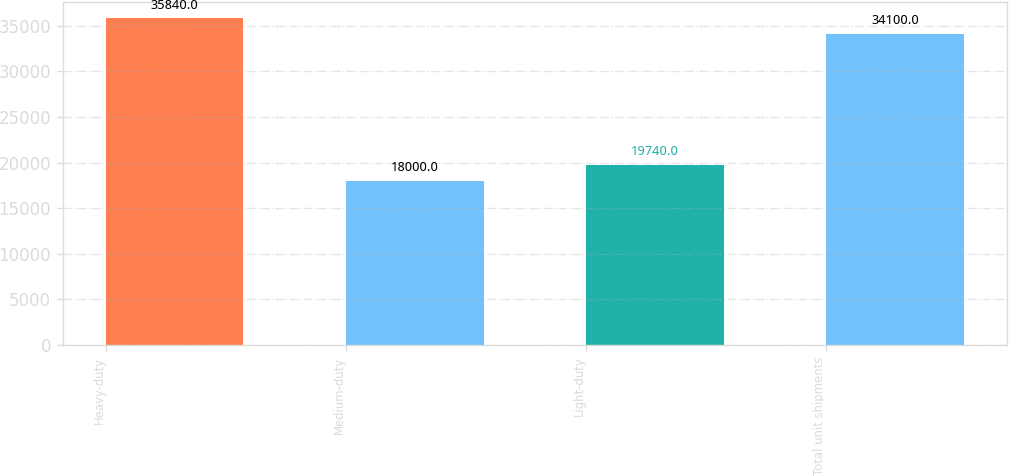<chart> <loc_0><loc_0><loc_500><loc_500><bar_chart><fcel>Heavy-duty<fcel>Medium-duty<fcel>Light-duty<fcel>Total unit shipments<nl><fcel>35840<fcel>18000<fcel>19740<fcel>34100<nl></chart> 